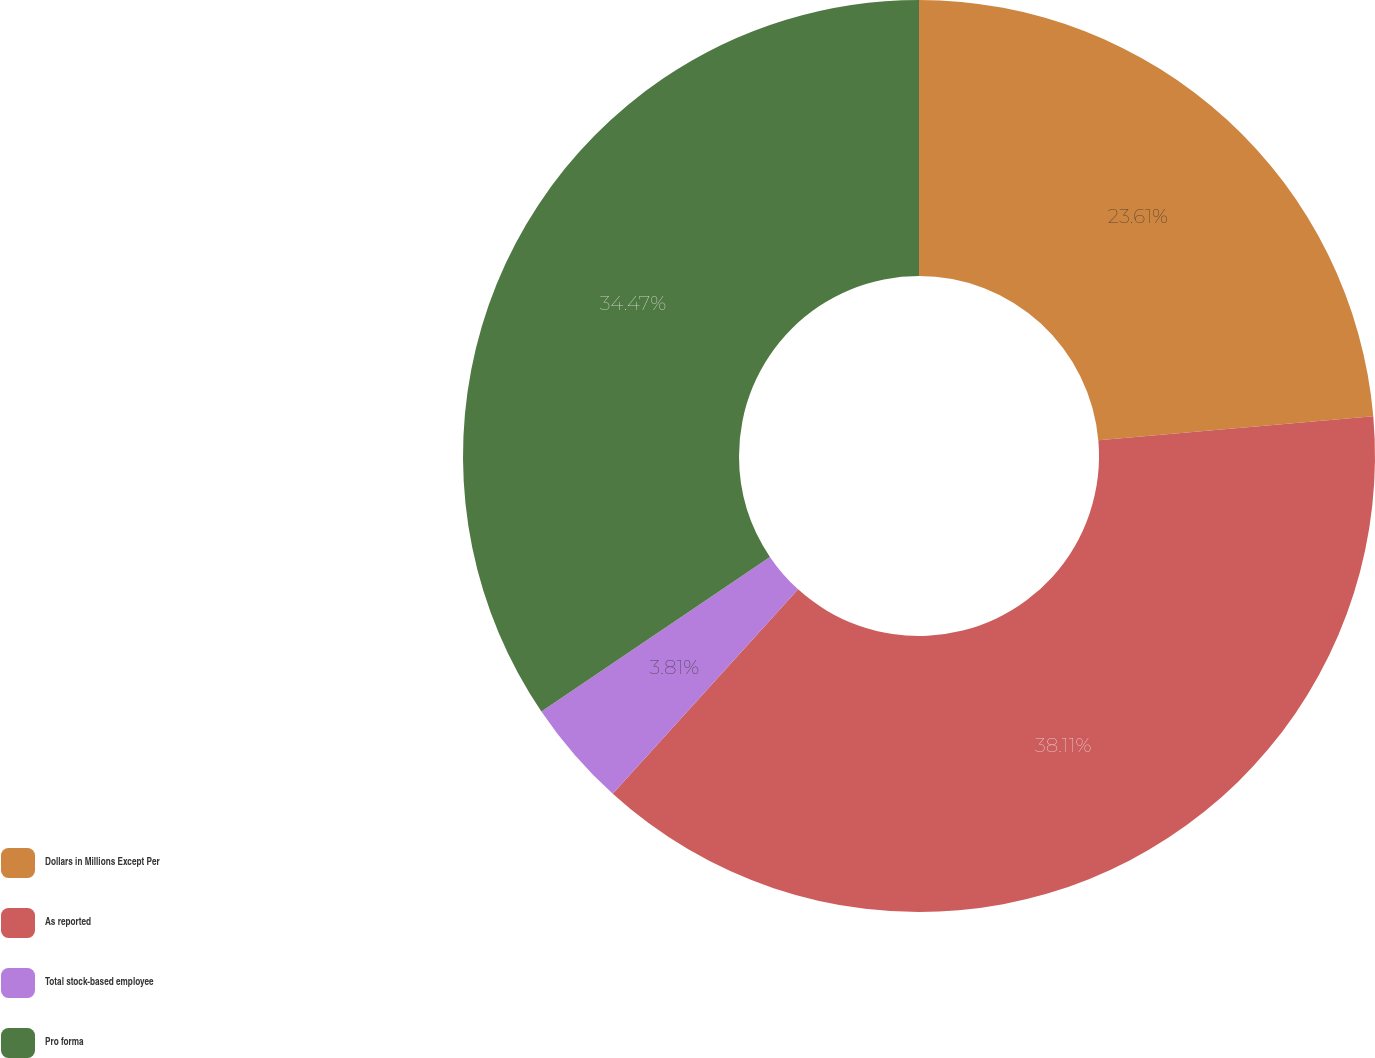Convert chart to OTSL. <chart><loc_0><loc_0><loc_500><loc_500><pie_chart><fcel>Dollars in Millions Except Per<fcel>As reported<fcel>Total stock-based employee<fcel>Pro forma<nl><fcel>23.61%<fcel>38.11%<fcel>3.81%<fcel>34.47%<nl></chart> 